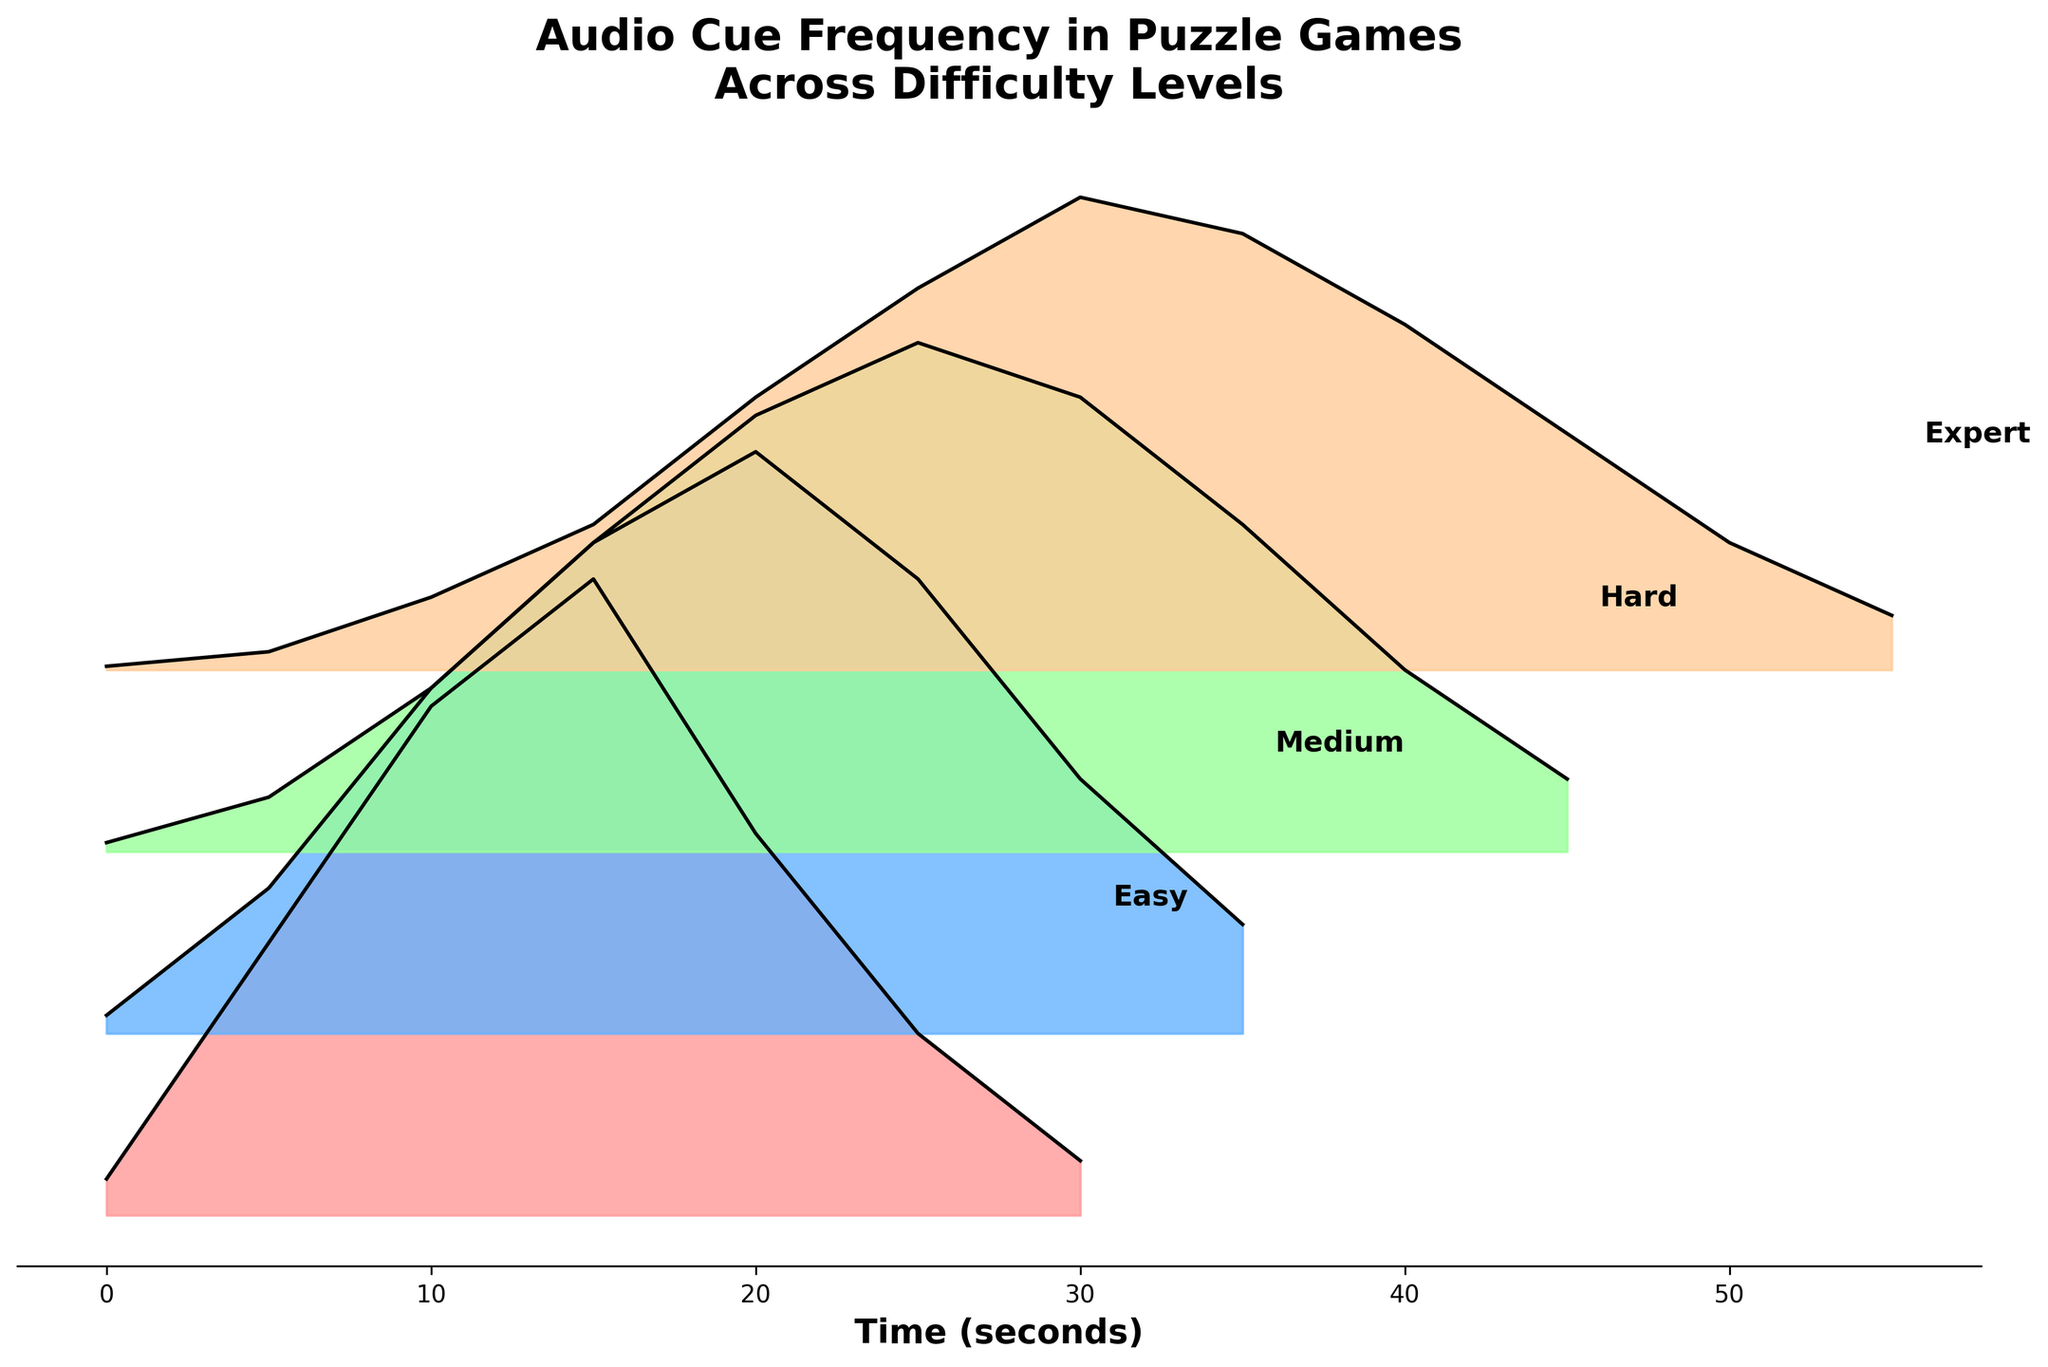What's the title of the figure? The title of the figure is prominently displayed at the top. It reads "Audio Cue Frequency in Puzzle Games Across Difficulty Levels."
Answer: Audio Cue Frequency in Puzzle Games Across Difficulty Levels What does the x-axis represent in the plot? The x-axis is labeled with "Time (seconds)," indicating that it represents the time in seconds during the game.
Answer: Time (seconds) What difficulty level shows the highest peak in frequency? The peaks of the frequency for each difficulty level can be visually identified by observing the maximum heights of the filled curves. The "Easy" difficulty level has the highest peak.
Answer: Easy Which difficulty levels have audio cues extending up to 35 seconds? By examining the lengths of the filled curves along the x-axis, we can see that "Medium," "Hard," and "Expert" all have audio cues that extend up to 35 seconds or more.
Answer: Medium, Hard, Expert How do the audio cues for "Expert" difficulty behave over time compared to "Easy" difficulty? Observing the shapes and heights of the ridgelines for "Expert" and "Easy": "Expert" has a gradual increase and more evenly distributed peaks, while "Easy" has a sharp peak around the 15-second mark and then drops off.
Answer: Expert difficulty has more evenly distributed peaks over time, whereas Easy difficulty has a sharp peak around 15 seconds What is the frequency at 10 seconds for "Hard" difficulty? By locating the point where the 10-second mark intersects with the ridgeline for "Hard" difficulty, we can see that the frequency is 0.9.
Answer: 0.9 Compare the maximum frequency values between "Medium" and "Hard" difficulties. By visually comparing the heights of the ridgelines for "Medium" and "Hard" difficulties, it is evident that "Medium" reaches a maximum frequency slightly above 3, while "Hard" reaches a maximum frequency around 2.8.
Answer: Medium has a higher maximum frequency What is the duration with no audio cues for "Easy" difficulty? Observing the "Easy" difficulty ridgeline, audio cues start at 0 seconds and go up to approximately 30 seconds. Therefore, there are no audio cues between 30-35 seconds.
Answer: 30-35 seconds Which difficulty level has the most gradual increase in frequency over time? By examining the slopes of the initial portions of the ridgelines, the "Expert" difficulty level shows the most gradual increase, with a smooth rise in frequency values over time.
Answer: Expert 